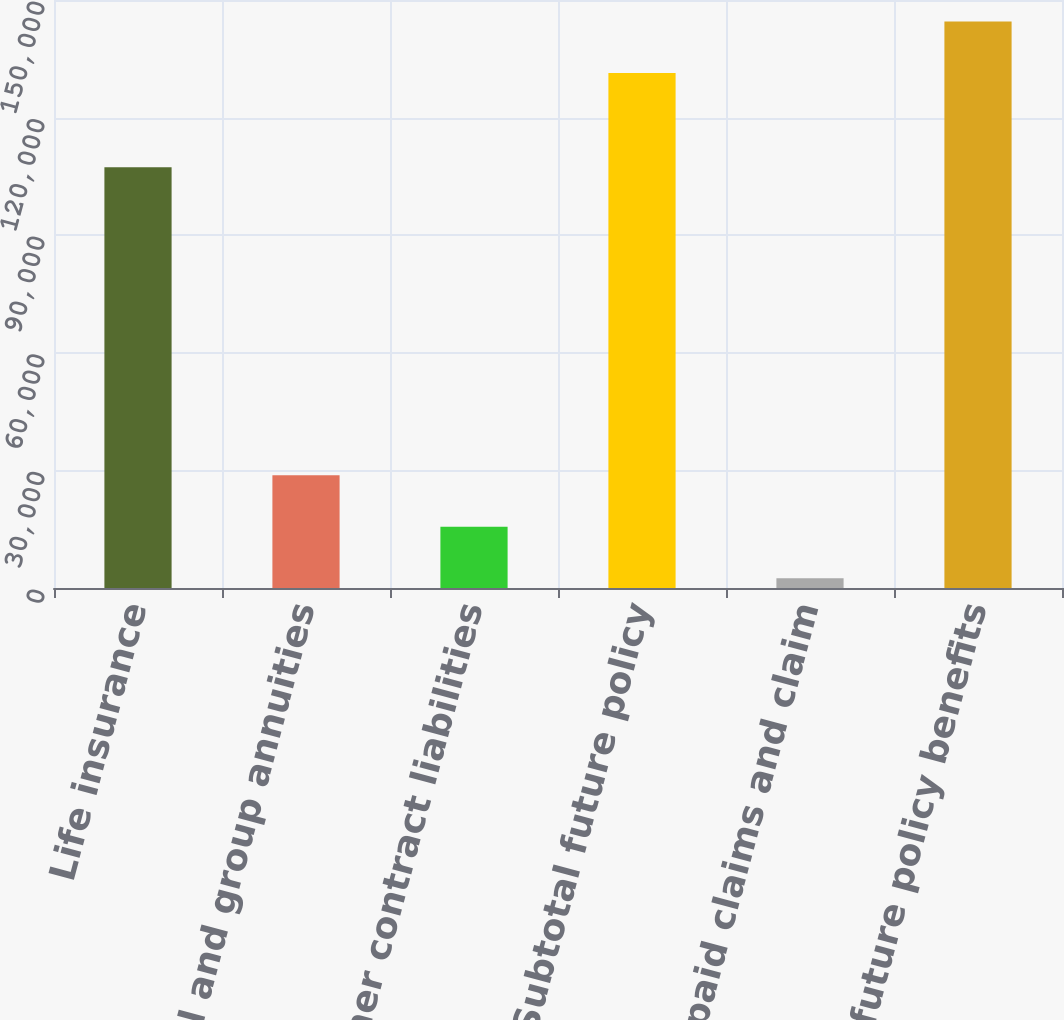Convert chart to OTSL. <chart><loc_0><loc_0><loc_500><loc_500><bar_chart><fcel>Life insurance<fcel>Individual and group annuities<fcel>Other contract liabilities<fcel>Subtotal future policy<fcel>Unpaid claims and claim<fcel>Total future policy benefits<nl><fcel>107320<fcel>28756.4<fcel>15616.7<fcel>131397<fcel>2477<fcel>144537<nl></chart> 